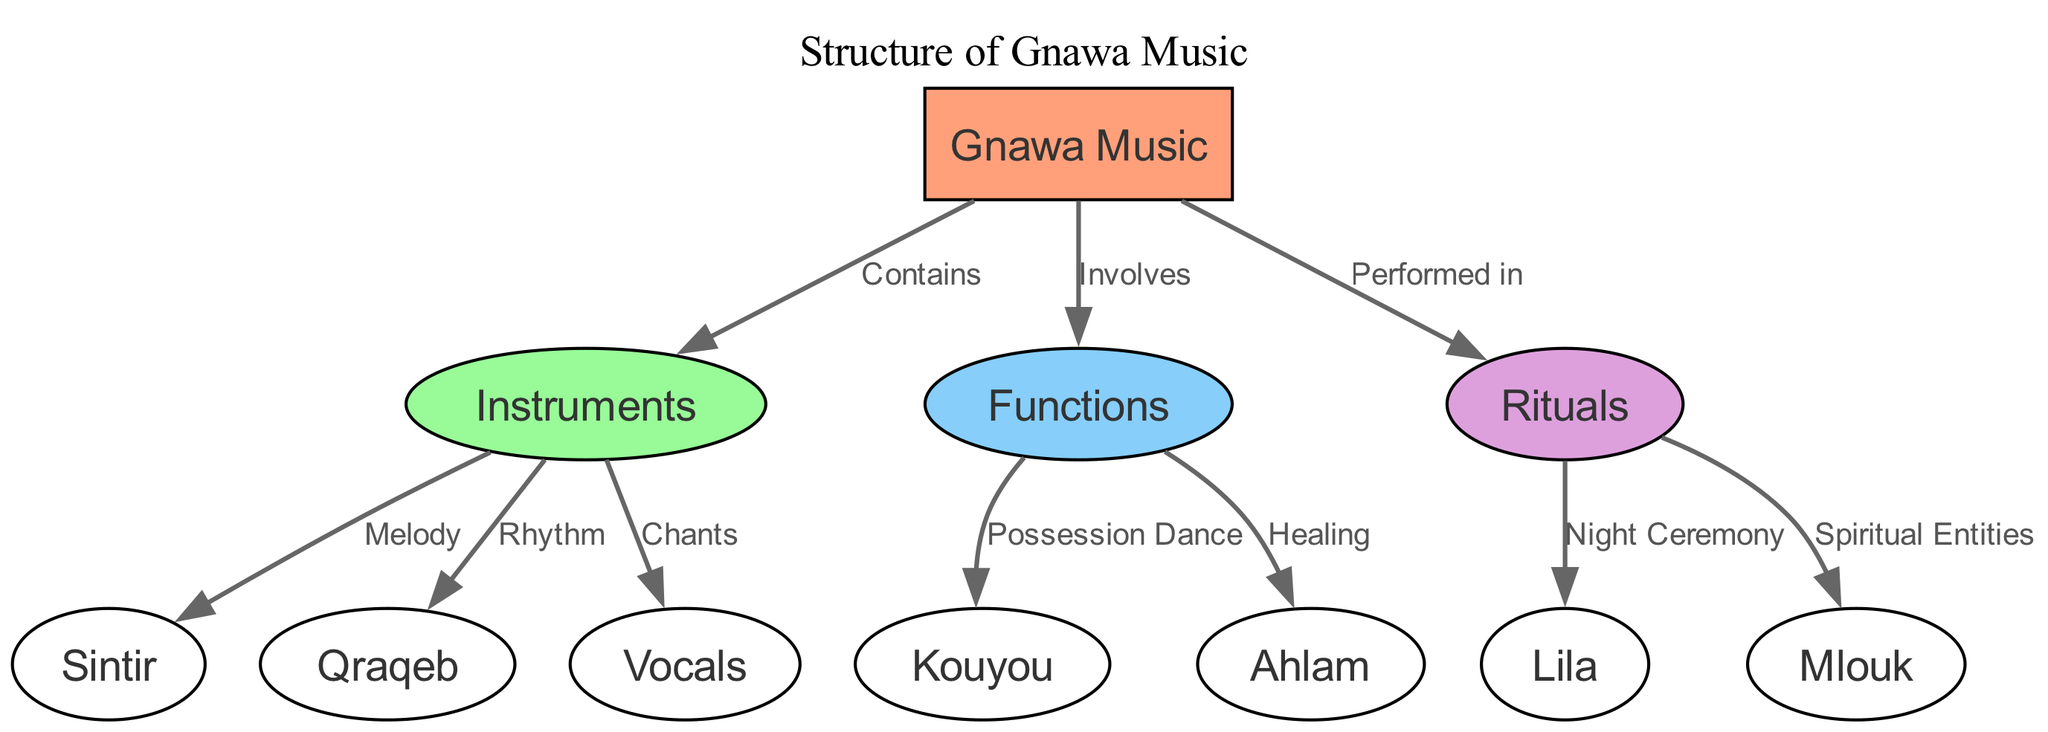What are the main components of Gnawa Music? The diagram lists "Instruments", "Functions", and "Rituals" as the main components that are part of Gnawa Music. These components are directly connected to the main node, which is "Gnawa Music".
Answer: Instruments, Functions, Rituals How many instruments are mentioned in the diagram? By reviewing the nodes related to "Instruments", there are three connecting nodes labeled "Sintir", "Qraqeb", and "Vocals". Therefore, the total count of instrument types is three.
Answer: 3 What is the function associated with possession dance? The diagram connects "Possession Dance" directly to "Functions", and it is represented as part of the functions of Gnawa Music. Thus, the answer is the specific function noted in the diagram.
Answer: Possession Dance Which ritual is related to spiritual entities? The edge from "Rituals" leading to "Spiritual Entities" indicates that there is a specific connection between these two nodes, showing that the ritual is directly associated with spiritual entities.
Answer: Spiritual Entities How many edges are there in the diagram? To determine the total number of edges, we should count each connection between nodes. There are seven edges visible connecting the different components of Gnawa Music.
Answer: 7 What theme does the "Lila" ritual represent? The diagram connects "Lila" to "Rituals", highlighting that "Lila" is part of the broader context of rituals in Gnawa Music. It specifically represents a night ceremony.
Answer: Night Ceremony What instrument provides the rhythm in Gnawa Music? Looking at the connections from the "Instruments" node, "Qraqeb" is specifically labeled as the instrument associated with rhythm, indicating its role within the structure of Gnawa Music.
Answer: Qraqeb Which component of Gnawa Music is primarily focused on healing? The diagram shows a direct link from "Functions" to "Healing". This indicates that healing is specifically identified as a function within the context of Gnawa Music.
Answer: Healing 